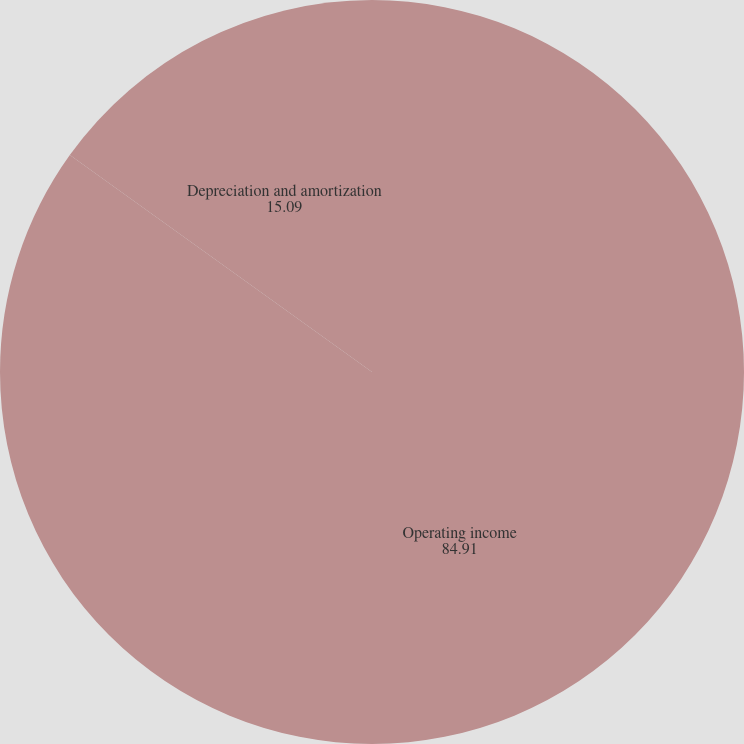Convert chart to OTSL. <chart><loc_0><loc_0><loc_500><loc_500><pie_chart><fcel>Operating income<fcel>Depreciation and amortization<nl><fcel>84.91%<fcel>15.09%<nl></chart> 